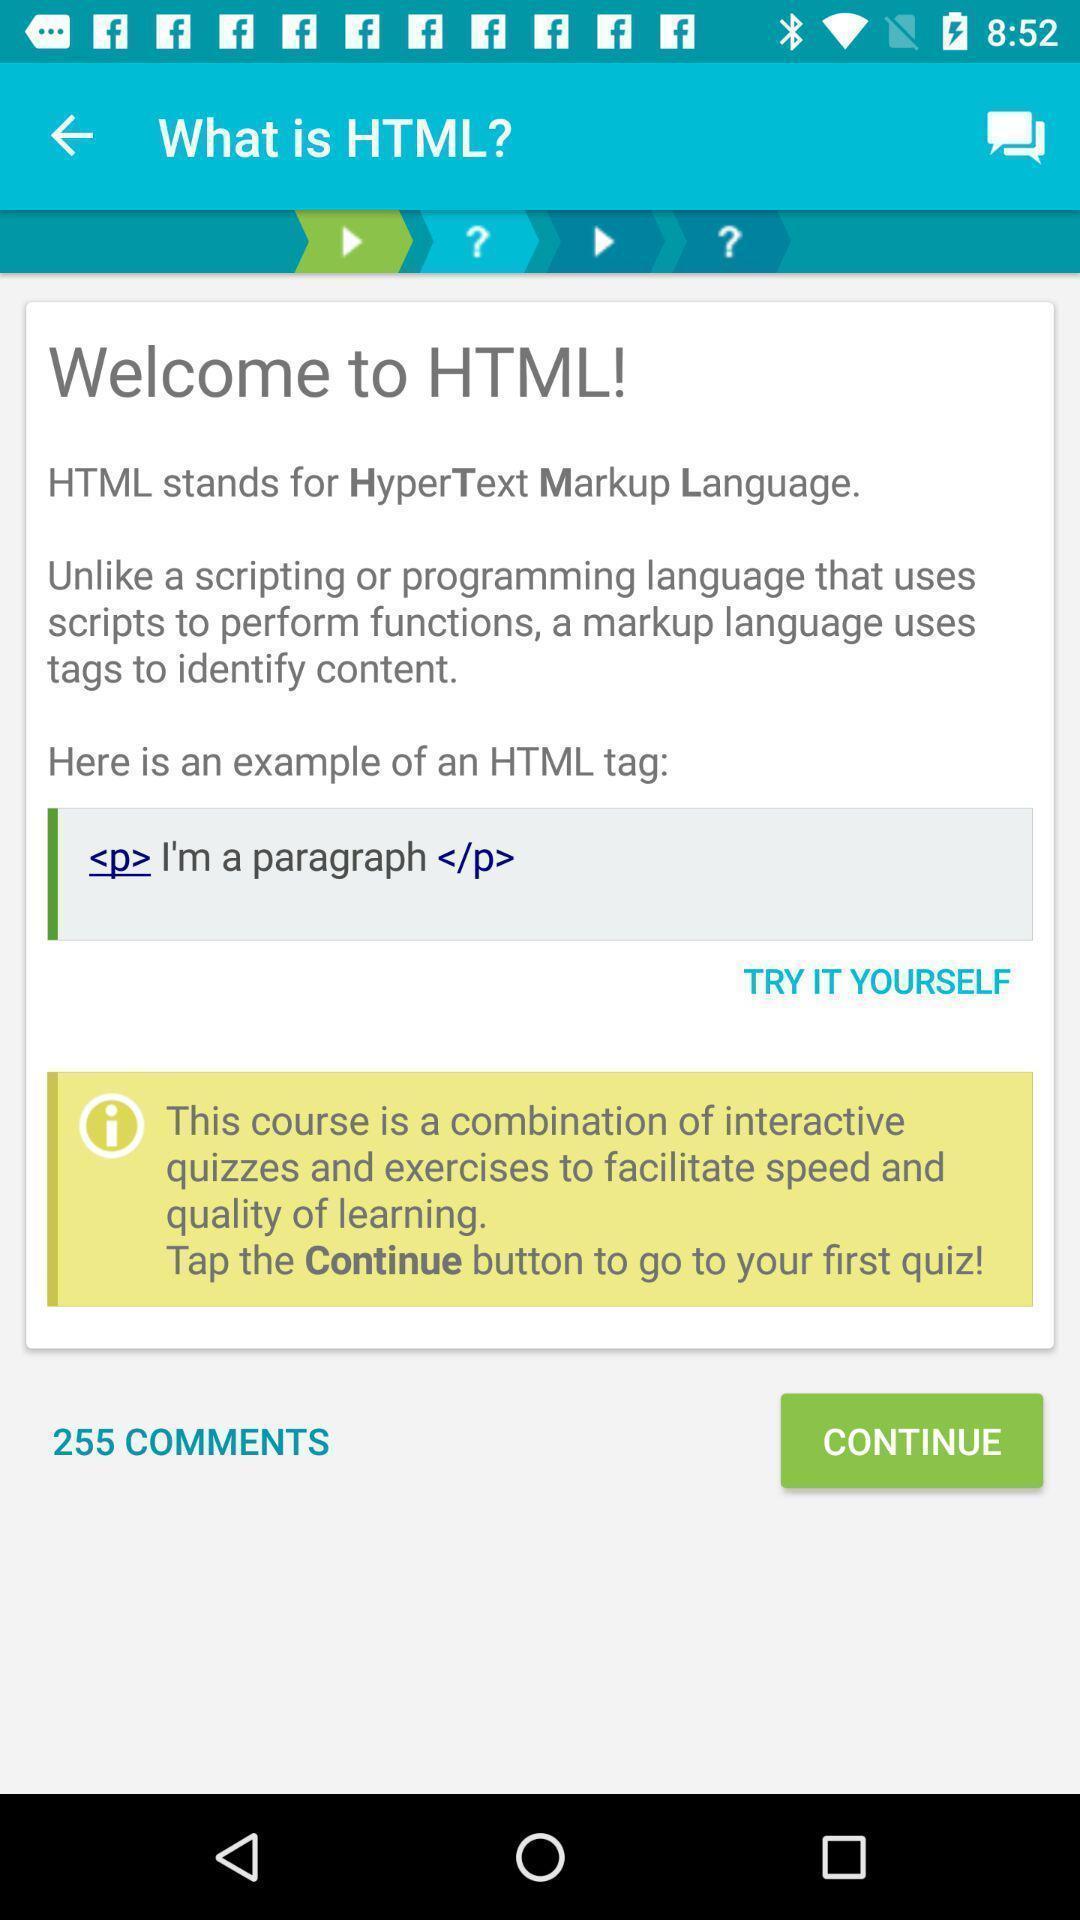Summarize the information in this screenshot. Welcoming page of a html. 